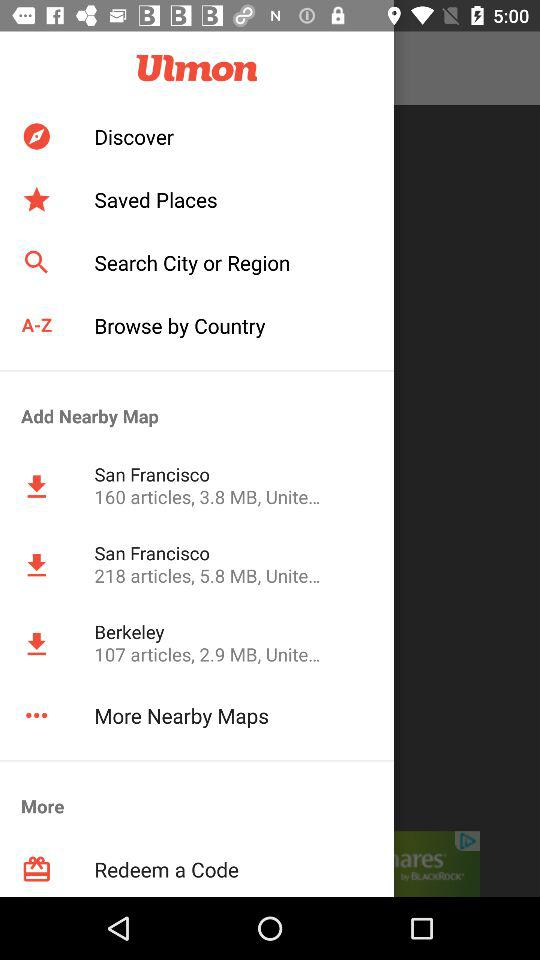What cities were added to the nearby map? The cities are San Francisco and Berkeley. 